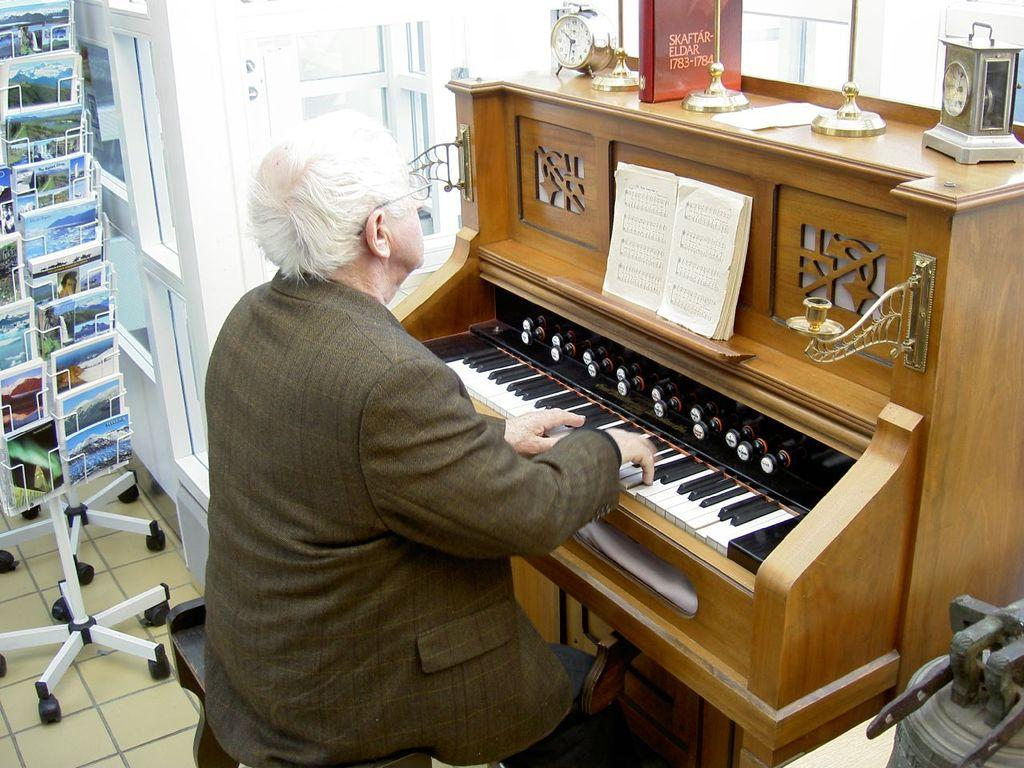What is the main subject of the image? The main subject of the image is a man. What is the man doing in the image? The man is sitting and playing a piano. What type of wound can be seen on the man's hand while he is playing the piano? There is no wound visible on the man's hand in the image. How much respect does the man receive from the audience while playing the piano? The image does not show an audience, so it is impossible to determine the amount of respect the man receives. 